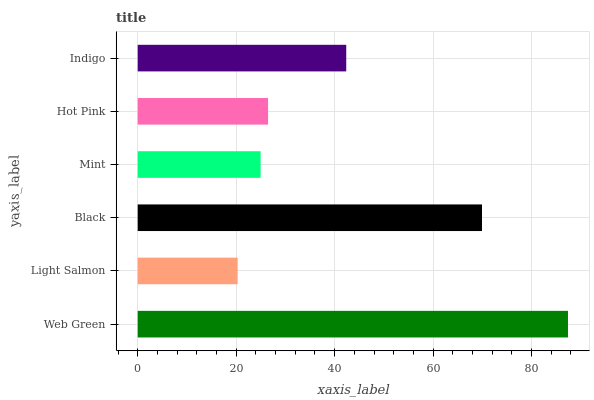Is Light Salmon the minimum?
Answer yes or no. Yes. Is Web Green the maximum?
Answer yes or no. Yes. Is Black the minimum?
Answer yes or no. No. Is Black the maximum?
Answer yes or no. No. Is Black greater than Light Salmon?
Answer yes or no. Yes. Is Light Salmon less than Black?
Answer yes or no. Yes. Is Light Salmon greater than Black?
Answer yes or no. No. Is Black less than Light Salmon?
Answer yes or no. No. Is Indigo the high median?
Answer yes or no. Yes. Is Hot Pink the low median?
Answer yes or no. Yes. Is Black the high median?
Answer yes or no. No. Is Indigo the low median?
Answer yes or no. No. 